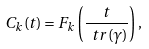<formula> <loc_0><loc_0><loc_500><loc_500>C _ { k } ( t ) = F _ { k } \left ( \frac { t } { \ t r ( \gamma ) } \right ) ,</formula> 